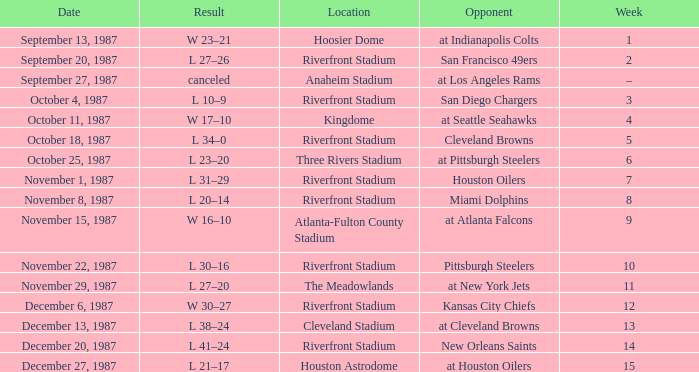What was the result of the game against the Miami Dolphins held at the Riverfront Stadium? L 20–14. Could you help me parse every detail presented in this table? {'header': ['Date', 'Result', 'Location', 'Opponent', 'Week'], 'rows': [['September 13, 1987', 'W 23–21', 'Hoosier Dome', 'at Indianapolis Colts', '1'], ['September 20, 1987', 'L 27–26', 'Riverfront Stadium', 'San Francisco 49ers', '2'], ['September 27, 1987', 'canceled', 'Anaheim Stadium', 'at Los Angeles Rams', '–'], ['October 4, 1987', 'L 10–9', 'Riverfront Stadium', 'San Diego Chargers', '3'], ['October 11, 1987', 'W 17–10', 'Kingdome', 'at Seattle Seahawks', '4'], ['October 18, 1987', 'L 34–0', 'Riverfront Stadium', 'Cleveland Browns', '5'], ['October 25, 1987', 'L 23–20', 'Three Rivers Stadium', 'at Pittsburgh Steelers', '6'], ['November 1, 1987', 'L 31–29', 'Riverfront Stadium', 'Houston Oilers', '7'], ['November 8, 1987', 'L 20–14', 'Riverfront Stadium', 'Miami Dolphins', '8'], ['November 15, 1987', 'W 16–10', 'Atlanta-Fulton County Stadium', 'at Atlanta Falcons', '9'], ['November 22, 1987', 'L 30–16', 'Riverfront Stadium', 'Pittsburgh Steelers', '10'], ['November 29, 1987', 'L 27–20', 'The Meadowlands', 'at New York Jets', '11'], ['December 6, 1987', 'W 30–27', 'Riverfront Stadium', 'Kansas City Chiefs', '12'], ['December 13, 1987', 'L 38–24', 'Cleveland Stadium', 'at Cleveland Browns', '13'], ['December 20, 1987', 'L 41–24', 'Riverfront Stadium', 'New Orleans Saints', '14'], ['December 27, 1987', 'L 21–17', 'Houston Astrodome', 'at Houston Oilers', '15']]} 